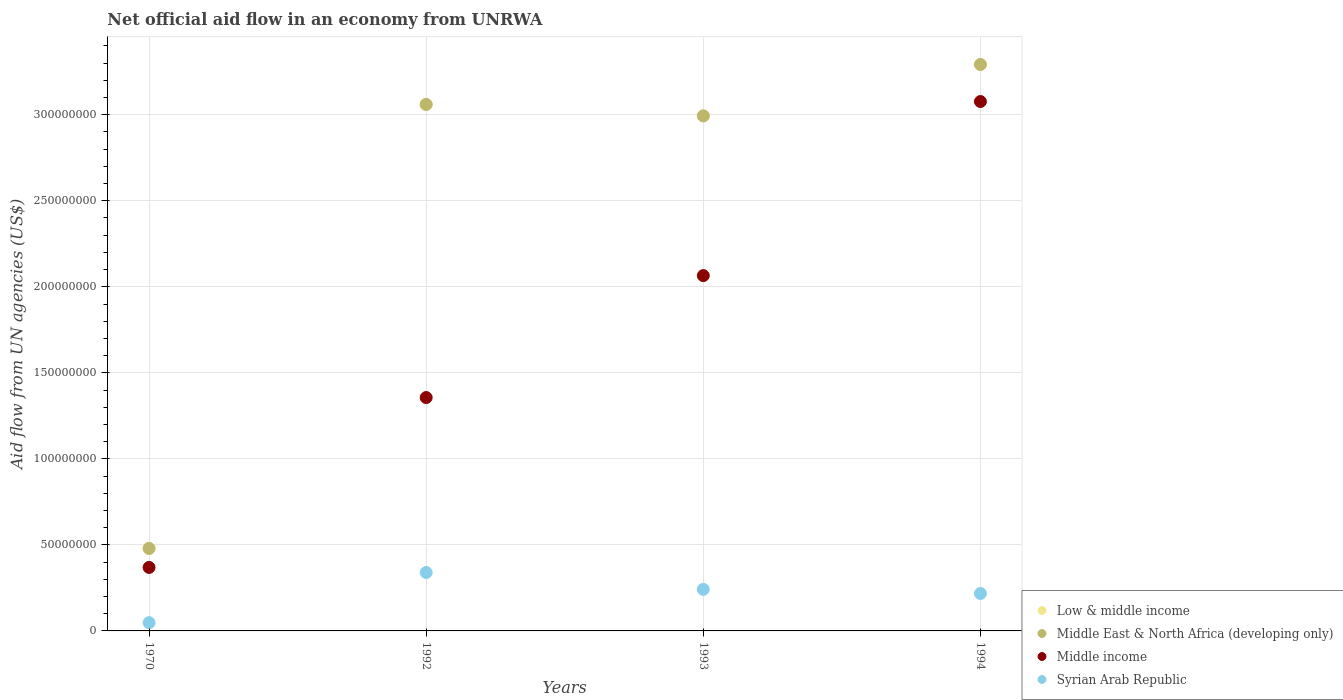What is the net official aid flow in Middle East & North Africa (developing only) in 1994?
Your answer should be compact. 3.29e+08. Across all years, what is the maximum net official aid flow in Middle East & North Africa (developing only)?
Make the answer very short. 3.29e+08. Across all years, what is the minimum net official aid flow in Syrian Arab Republic?
Your answer should be compact. 4.79e+06. What is the total net official aid flow in Middle East & North Africa (developing only) in the graph?
Offer a terse response. 9.82e+08. What is the difference between the net official aid flow in Low & middle income in 1970 and that in 1992?
Make the answer very short. -2.58e+08. What is the difference between the net official aid flow in Middle East & North Africa (developing only) in 1992 and the net official aid flow in Syrian Arab Republic in 1970?
Your answer should be very brief. 3.01e+08. What is the average net official aid flow in Middle income per year?
Provide a short and direct response. 1.72e+08. In the year 1994, what is the difference between the net official aid flow in Middle income and net official aid flow in Low & middle income?
Make the answer very short. -2.15e+07. What is the ratio of the net official aid flow in Syrian Arab Republic in 1992 to that in 1994?
Your answer should be very brief. 1.56. Is the net official aid flow in Syrian Arab Republic in 1970 less than that in 1992?
Your response must be concise. Yes. Is the difference between the net official aid flow in Middle income in 1970 and 1993 greater than the difference between the net official aid flow in Low & middle income in 1970 and 1993?
Offer a terse response. Yes. What is the difference between the highest and the second highest net official aid flow in Middle East & North Africa (developing only)?
Your answer should be very brief. 2.32e+07. What is the difference between the highest and the lowest net official aid flow in Low & middle income?
Offer a very short reply. 2.81e+08. Is it the case that in every year, the sum of the net official aid flow in Middle East & North Africa (developing only) and net official aid flow in Low & middle income  is greater than the net official aid flow in Syrian Arab Republic?
Ensure brevity in your answer.  Yes. Does the net official aid flow in Low & middle income monotonically increase over the years?
Keep it short and to the point. No. Is the net official aid flow in Middle income strictly greater than the net official aid flow in Middle East & North Africa (developing only) over the years?
Make the answer very short. No. Is the net official aid flow in Middle East & North Africa (developing only) strictly less than the net official aid flow in Low & middle income over the years?
Make the answer very short. No. Does the graph contain any zero values?
Your answer should be very brief. No. Where does the legend appear in the graph?
Keep it short and to the point. Bottom right. How many legend labels are there?
Keep it short and to the point. 4. How are the legend labels stacked?
Provide a succinct answer. Vertical. What is the title of the graph?
Provide a short and direct response. Net official aid flow in an economy from UNRWA. Does "Congo (Democratic)" appear as one of the legend labels in the graph?
Ensure brevity in your answer.  No. What is the label or title of the Y-axis?
Your answer should be compact. Aid flow from UN agencies (US$). What is the Aid flow from UN agencies (US$) of Low & middle income in 1970?
Give a very brief answer. 4.79e+07. What is the Aid flow from UN agencies (US$) in Middle East & North Africa (developing only) in 1970?
Your answer should be very brief. 4.79e+07. What is the Aid flow from UN agencies (US$) of Middle income in 1970?
Keep it short and to the point. 3.69e+07. What is the Aid flow from UN agencies (US$) of Syrian Arab Republic in 1970?
Your response must be concise. 4.79e+06. What is the Aid flow from UN agencies (US$) in Low & middle income in 1992?
Provide a short and direct response. 3.06e+08. What is the Aid flow from UN agencies (US$) of Middle East & North Africa (developing only) in 1992?
Offer a terse response. 3.06e+08. What is the Aid flow from UN agencies (US$) of Middle income in 1992?
Offer a terse response. 1.36e+08. What is the Aid flow from UN agencies (US$) in Syrian Arab Republic in 1992?
Provide a short and direct response. 3.40e+07. What is the Aid flow from UN agencies (US$) of Low & middle income in 1993?
Your response must be concise. 2.99e+08. What is the Aid flow from UN agencies (US$) of Middle East & North Africa (developing only) in 1993?
Provide a short and direct response. 2.99e+08. What is the Aid flow from UN agencies (US$) of Middle income in 1993?
Provide a short and direct response. 2.07e+08. What is the Aid flow from UN agencies (US$) of Syrian Arab Republic in 1993?
Offer a terse response. 2.42e+07. What is the Aid flow from UN agencies (US$) of Low & middle income in 1994?
Offer a terse response. 3.29e+08. What is the Aid flow from UN agencies (US$) in Middle East & North Africa (developing only) in 1994?
Make the answer very short. 3.29e+08. What is the Aid flow from UN agencies (US$) in Middle income in 1994?
Your response must be concise. 3.08e+08. What is the Aid flow from UN agencies (US$) in Syrian Arab Republic in 1994?
Keep it short and to the point. 2.18e+07. Across all years, what is the maximum Aid flow from UN agencies (US$) of Low & middle income?
Ensure brevity in your answer.  3.29e+08. Across all years, what is the maximum Aid flow from UN agencies (US$) of Middle East & North Africa (developing only)?
Your answer should be compact. 3.29e+08. Across all years, what is the maximum Aid flow from UN agencies (US$) in Middle income?
Provide a short and direct response. 3.08e+08. Across all years, what is the maximum Aid flow from UN agencies (US$) in Syrian Arab Republic?
Offer a very short reply. 3.40e+07. Across all years, what is the minimum Aid flow from UN agencies (US$) in Low & middle income?
Your answer should be compact. 4.79e+07. Across all years, what is the minimum Aid flow from UN agencies (US$) in Middle East & North Africa (developing only)?
Offer a terse response. 4.79e+07. Across all years, what is the minimum Aid flow from UN agencies (US$) in Middle income?
Keep it short and to the point. 3.69e+07. Across all years, what is the minimum Aid flow from UN agencies (US$) in Syrian Arab Republic?
Offer a very short reply. 4.79e+06. What is the total Aid flow from UN agencies (US$) of Low & middle income in the graph?
Ensure brevity in your answer.  9.82e+08. What is the total Aid flow from UN agencies (US$) in Middle East & North Africa (developing only) in the graph?
Your answer should be very brief. 9.82e+08. What is the total Aid flow from UN agencies (US$) of Middle income in the graph?
Give a very brief answer. 6.87e+08. What is the total Aid flow from UN agencies (US$) of Syrian Arab Republic in the graph?
Offer a very short reply. 8.46e+07. What is the difference between the Aid flow from UN agencies (US$) in Low & middle income in 1970 and that in 1992?
Your answer should be compact. -2.58e+08. What is the difference between the Aid flow from UN agencies (US$) in Middle East & North Africa (developing only) in 1970 and that in 1992?
Make the answer very short. -2.58e+08. What is the difference between the Aid flow from UN agencies (US$) in Middle income in 1970 and that in 1992?
Give a very brief answer. -9.87e+07. What is the difference between the Aid flow from UN agencies (US$) in Syrian Arab Republic in 1970 and that in 1992?
Your answer should be compact. -2.92e+07. What is the difference between the Aid flow from UN agencies (US$) in Low & middle income in 1970 and that in 1993?
Provide a succinct answer. -2.51e+08. What is the difference between the Aid flow from UN agencies (US$) of Middle East & North Africa (developing only) in 1970 and that in 1993?
Your answer should be very brief. -2.51e+08. What is the difference between the Aid flow from UN agencies (US$) in Middle income in 1970 and that in 1993?
Your answer should be very brief. -1.70e+08. What is the difference between the Aid flow from UN agencies (US$) of Syrian Arab Republic in 1970 and that in 1993?
Offer a terse response. -1.94e+07. What is the difference between the Aid flow from UN agencies (US$) of Low & middle income in 1970 and that in 1994?
Offer a very short reply. -2.81e+08. What is the difference between the Aid flow from UN agencies (US$) of Middle East & North Africa (developing only) in 1970 and that in 1994?
Your answer should be compact. -2.81e+08. What is the difference between the Aid flow from UN agencies (US$) of Middle income in 1970 and that in 1994?
Your answer should be very brief. -2.71e+08. What is the difference between the Aid flow from UN agencies (US$) of Syrian Arab Republic in 1970 and that in 1994?
Your answer should be compact. -1.70e+07. What is the difference between the Aid flow from UN agencies (US$) of Low & middle income in 1992 and that in 1993?
Keep it short and to the point. 6.65e+06. What is the difference between the Aid flow from UN agencies (US$) in Middle East & North Africa (developing only) in 1992 and that in 1993?
Ensure brevity in your answer.  6.65e+06. What is the difference between the Aid flow from UN agencies (US$) in Middle income in 1992 and that in 1993?
Your answer should be very brief. -7.09e+07. What is the difference between the Aid flow from UN agencies (US$) in Syrian Arab Republic in 1992 and that in 1993?
Make the answer very short. 9.80e+06. What is the difference between the Aid flow from UN agencies (US$) of Low & middle income in 1992 and that in 1994?
Provide a succinct answer. -2.32e+07. What is the difference between the Aid flow from UN agencies (US$) of Middle East & North Africa (developing only) in 1992 and that in 1994?
Your response must be concise. -2.32e+07. What is the difference between the Aid flow from UN agencies (US$) in Middle income in 1992 and that in 1994?
Your response must be concise. -1.72e+08. What is the difference between the Aid flow from UN agencies (US$) of Syrian Arab Republic in 1992 and that in 1994?
Give a very brief answer. 1.22e+07. What is the difference between the Aid flow from UN agencies (US$) in Low & middle income in 1993 and that in 1994?
Give a very brief answer. -2.99e+07. What is the difference between the Aid flow from UN agencies (US$) in Middle East & North Africa (developing only) in 1993 and that in 1994?
Make the answer very short. -2.99e+07. What is the difference between the Aid flow from UN agencies (US$) of Middle income in 1993 and that in 1994?
Keep it short and to the point. -1.01e+08. What is the difference between the Aid flow from UN agencies (US$) of Syrian Arab Republic in 1993 and that in 1994?
Keep it short and to the point. 2.40e+06. What is the difference between the Aid flow from UN agencies (US$) of Low & middle income in 1970 and the Aid flow from UN agencies (US$) of Middle East & North Africa (developing only) in 1992?
Offer a terse response. -2.58e+08. What is the difference between the Aid flow from UN agencies (US$) of Low & middle income in 1970 and the Aid flow from UN agencies (US$) of Middle income in 1992?
Make the answer very short. -8.77e+07. What is the difference between the Aid flow from UN agencies (US$) of Low & middle income in 1970 and the Aid flow from UN agencies (US$) of Syrian Arab Republic in 1992?
Ensure brevity in your answer.  1.40e+07. What is the difference between the Aid flow from UN agencies (US$) in Middle East & North Africa (developing only) in 1970 and the Aid flow from UN agencies (US$) in Middle income in 1992?
Offer a very short reply. -8.77e+07. What is the difference between the Aid flow from UN agencies (US$) in Middle East & North Africa (developing only) in 1970 and the Aid flow from UN agencies (US$) in Syrian Arab Republic in 1992?
Your answer should be very brief. 1.40e+07. What is the difference between the Aid flow from UN agencies (US$) in Middle income in 1970 and the Aid flow from UN agencies (US$) in Syrian Arab Republic in 1992?
Give a very brief answer. 2.95e+06. What is the difference between the Aid flow from UN agencies (US$) in Low & middle income in 1970 and the Aid flow from UN agencies (US$) in Middle East & North Africa (developing only) in 1993?
Your response must be concise. -2.51e+08. What is the difference between the Aid flow from UN agencies (US$) in Low & middle income in 1970 and the Aid flow from UN agencies (US$) in Middle income in 1993?
Keep it short and to the point. -1.59e+08. What is the difference between the Aid flow from UN agencies (US$) in Low & middle income in 1970 and the Aid flow from UN agencies (US$) in Syrian Arab Republic in 1993?
Keep it short and to the point. 2.38e+07. What is the difference between the Aid flow from UN agencies (US$) of Middle East & North Africa (developing only) in 1970 and the Aid flow from UN agencies (US$) of Middle income in 1993?
Give a very brief answer. -1.59e+08. What is the difference between the Aid flow from UN agencies (US$) in Middle East & North Africa (developing only) in 1970 and the Aid flow from UN agencies (US$) in Syrian Arab Republic in 1993?
Make the answer very short. 2.38e+07. What is the difference between the Aid flow from UN agencies (US$) in Middle income in 1970 and the Aid flow from UN agencies (US$) in Syrian Arab Republic in 1993?
Ensure brevity in your answer.  1.28e+07. What is the difference between the Aid flow from UN agencies (US$) of Low & middle income in 1970 and the Aid flow from UN agencies (US$) of Middle East & North Africa (developing only) in 1994?
Your response must be concise. -2.81e+08. What is the difference between the Aid flow from UN agencies (US$) of Low & middle income in 1970 and the Aid flow from UN agencies (US$) of Middle income in 1994?
Provide a succinct answer. -2.60e+08. What is the difference between the Aid flow from UN agencies (US$) of Low & middle income in 1970 and the Aid flow from UN agencies (US$) of Syrian Arab Republic in 1994?
Provide a short and direct response. 2.62e+07. What is the difference between the Aid flow from UN agencies (US$) of Middle East & North Africa (developing only) in 1970 and the Aid flow from UN agencies (US$) of Middle income in 1994?
Keep it short and to the point. -2.60e+08. What is the difference between the Aid flow from UN agencies (US$) in Middle East & North Africa (developing only) in 1970 and the Aid flow from UN agencies (US$) in Syrian Arab Republic in 1994?
Your answer should be compact. 2.62e+07. What is the difference between the Aid flow from UN agencies (US$) of Middle income in 1970 and the Aid flow from UN agencies (US$) of Syrian Arab Republic in 1994?
Give a very brief answer. 1.52e+07. What is the difference between the Aid flow from UN agencies (US$) in Low & middle income in 1992 and the Aid flow from UN agencies (US$) in Middle East & North Africa (developing only) in 1993?
Your answer should be compact. 6.65e+06. What is the difference between the Aid flow from UN agencies (US$) of Low & middle income in 1992 and the Aid flow from UN agencies (US$) of Middle income in 1993?
Ensure brevity in your answer.  9.95e+07. What is the difference between the Aid flow from UN agencies (US$) of Low & middle income in 1992 and the Aid flow from UN agencies (US$) of Syrian Arab Republic in 1993?
Provide a short and direct response. 2.82e+08. What is the difference between the Aid flow from UN agencies (US$) in Middle East & North Africa (developing only) in 1992 and the Aid flow from UN agencies (US$) in Middle income in 1993?
Offer a very short reply. 9.95e+07. What is the difference between the Aid flow from UN agencies (US$) of Middle East & North Africa (developing only) in 1992 and the Aid flow from UN agencies (US$) of Syrian Arab Republic in 1993?
Provide a succinct answer. 2.82e+08. What is the difference between the Aid flow from UN agencies (US$) of Middle income in 1992 and the Aid flow from UN agencies (US$) of Syrian Arab Republic in 1993?
Ensure brevity in your answer.  1.11e+08. What is the difference between the Aid flow from UN agencies (US$) in Low & middle income in 1992 and the Aid flow from UN agencies (US$) in Middle East & North Africa (developing only) in 1994?
Your response must be concise. -2.32e+07. What is the difference between the Aid flow from UN agencies (US$) in Low & middle income in 1992 and the Aid flow from UN agencies (US$) in Middle income in 1994?
Keep it short and to the point. -1.70e+06. What is the difference between the Aid flow from UN agencies (US$) of Low & middle income in 1992 and the Aid flow from UN agencies (US$) of Syrian Arab Republic in 1994?
Keep it short and to the point. 2.84e+08. What is the difference between the Aid flow from UN agencies (US$) of Middle East & North Africa (developing only) in 1992 and the Aid flow from UN agencies (US$) of Middle income in 1994?
Your response must be concise. -1.70e+06. What is the difference between the Aid flow from UN agencies (US$) of Middle East & North Africa (developing only) in 1992 and the Aid flow from UN agencies (US$) of Syrian Arab Republic in 1994?
Provide a short and direct response. 2.84e+08. What is the difference between the Aid flow from UN agencies (US$) of Middle income in 1992 and the Aid flow from UN agencies (US$) of Syrian Arab Republic in 1994?
Provide a succinct answer. 1.14e+08. What is the difference between the Aid flow from UN agencies (US$) in Low & middle income in 1993 and the Aid flow from UN agencies (US$) in Middle East & North Africa (developing only) in 1994?
Provide a succinct answer. -2.99e+07. What is the difference between the Aid flow from UN agencies (US$) in Low & middle income in 1993 and the Aid flow from UN agencies (US$) in Middle income in 1994?
Your answer should be compact. -8.35e+06. What is the difference between the Aid flow from UN agencies (US$) of Low & middle income in 1993 and the Aid flow from UN agencies (US$) of Syrian Arab Republic in 1994?
Your answer should be very brief. 2.78e+08. What is the difference between the Aid flow from UN agencies (US$) of Middle East & North Africa (developing only) in 1993 and the Aid flow from UN agencies (US$) of Middle income in 1994?
Offer a very short reply. -8.35e+06. What is the difference between the Aid flow from UN agencies (US$) of Middle East & North Africa (developing only) in 1993 and the Aid flow from UN agencies (US$) of Syrian Arab Republic in 1994?
Give a very brief answer. 2.78e+08. What is the difference between the Aid flow from UN agencies (US$) of Middle income in 1993 and the Aid flow from UN agencies (US$) of Syrian Arab Republic in 1994?
Your answer should be very brief. 1.85e+08. What is the average Aid flow from UN agencies (US$) in Low & middle income per year?
Provide a short and direct response. 2.46e+08. What is the average Aid flow from UN agencies (US$) in Middle East & North Africa (developing only) per year?
Offer a very short reply. 2.46e+08. What is the average Aid flow from UN agencies (US$) of Middle income per year?
Provide a short and direct response. 1.72e+08. What is the average Aid flow from UN agencies (US$) in Syrian Arab Republic per year?
Provide a short and direct response. 2.12e+07. In the year 1970, what is the difference between the Aid flow from UN agencies (US$) of Low & middle income and Aid flow from UN agencies (US$) of Middle East & North Africa (developing only)?
Provide a succinct answer. 0. In the year 1970, what is the difference between the Aid flow from UN agencies (US$) in Low & middle income and Aid flow from UN agencies (US$) in Middle income?
Provide a succinct answer. 1.10e+07. In the year 1970, what is the difference between the Aid flow from UN agencies (US$) of Low & middle income and Aid flow from UN agencies (US$) of Syrian Arab Republic?
Your answer should be compact. 4.31e+07. In the year 1970, what is the difference between the Aid flow from UN agencies (US$) of Middle East & North Africa (developing only) and Aid flow from UN agencies (US$) of Middle income?
Make the answer very short. 1.10e+07. In the year 1970, what is the difference between the Aid flow from UN agencies (US$) in Middle East & North Africa (developing only) and Aid flow from UN agencies (US$) in Syrian Arab Republic?
Make the answer very short. 4.31e+07. In the year 1970, what is the difference between the Aid flow from UN agencies (US$) of Middle income and Aid flow from UN agencies (US$) of Syrian Arab Republic?
Ensure brevity in your answer.  3.21e+07. In the year 1992, what is the difference between the Aid flow from UN agencies (US$) in Low & middle income and Aid flow from UN agencies (US$) in Middle East & North Africa (developing only)?
Provide a succinct answer. 0. In the year 1992, what is the difference between the Aid flow from UN agencies (US$) in Low & middle income and Aid flow from UN agencies (US$) in Middle income?
Your answer should be very brief. 1.70e+08. In the year 1992, what is the difference between the Aid flow from UN agencies (US$) of Low & middle income and Aid flow from UN agencies (US$) of Syrian Arab Republic?
Offer a terse response. 2.72e+08. In the year 1992, what is the difference between the Aid flow from UN agencies (US$) of Middle East & North Africa (developing only) and Aid flow from UN agencies (US$) of Middle income?
Make the answer very short. 1.70e+08. In the year 1992, what is the difference between the Aid flow from UN agencies (US$) in Middle East & North Africa (developing only) and Aid flow from UN agencies (US$) in Syrian Arab Republic?
Make the answer very short. 2.72e+08. In the year 1992, what is the difference between the Aid flow from UN agencies (US$) of Middle income and Aid flow from UN agencies (US$) of Syrian Arab Republic?
Offer a terse response. 1.02e+08. In the year 1993, what is the difference between the Aid flow from UN agencies (US$) in Low & middle income and Aid flow from UN agencies (US$) in Middle income?
Your answer should be very brief. 9.28e+07. In the year 1993, what is the difference between the Aid flow from UN agencies (US$) in Low & middle income and Aid flow from UN agencies (US$) in Syrian Arab Republic?
Ensure brevity in your answer.  2.75e+08. In the year 1993, what is the difference between the Aid flow from UN agencies (US$) of Middle East & North Africa (developing only) and Aid flow from UN agencies (US$) of Middle income?
Offer a very short reply. 9.28e+07. In the year 1993, what is the difference between the Aid flow from UN agencies (US$) of Middle East & North Africa (developing only) and Aid flow from UN agencies (US$) of Syrian Arab Republic?
Give a very brief answer. 2.75e+08. In the year 1993, what is the difference between the Aid flow from UN agencies (US$) of Middle income and Aid flow from UN agencies (US$) of Syrian Arab Republic?
Keep it short and to the point. 1.82e+08. In the year 1994, what is the difference between the Aid flow from UN agencies (US$) of Low & middle income and Aid flow from UN agencies (US$) of Middle income?
Your answer should be compact. 2.15e+07. In the year 1994, what is the difference between the Aid flow from UN agencies (US$) of Low & middle income and Aid flow from UN agencies (US$) of Syrian Arab Republic?
Your response must be concise. 3.07e+08. In the year 1994, what is the difference between the Aid flow from UN agencies (US$) in Middle East & North Africa (developing only) and Aid flow from UN agencies (US$) in Middle income?
Provide a short and direct response. 2.15e+07. In the year 1994, what is the difference between the Aid flow from UN agencies (US$) of Middle East & North Africa (developing only) and Aid flow from UN agencies (US$) of Syrian Arab Republic?
Provide a succinct answer. 3.07e+08. In the year 1994, what is the difference between the Aid flow from UN agencies (US$) of Middle income and Aid flow from UN agencies (US$) of Syrian Arab Republic?
Your answer should be very brief. 2.86e+08. What is the ratio of the Aid flow from UN agencies (US$) of Low & middle income in 1970 to that in 1992?
Your answer should be compact. 0.16. What is the ratio of the Aid flow from UN agencies (US$) of Middle East & North Africa (developing only) in 1970 to that in 1992?
Your answer should be compact. 0.16. What is the ratio of the Aid flow from UN agencies (US$) in Middle income in 1970 to that in 1992?
Your answer should be very brief. 0.27. What is the ratio of the Aid flow from UN agencies (US$) of Syrian Arab Republic in 1970 to that in 1992?
Provide a succinct answer. 0.14. What is the ratio of the Aid flow from UN agencies (US$) in Low & middle income in 1970 to that in 1993?
Your answer should be compact. 0.16. What is the ratio of the Aid flow from UN agencies (US$) of Middle East & North Africa (developing only) in 1970 to that in 1993?
Offer a very short reply. 0.16. What is the ratio of the Aid flow from UN agencies (US$) in Middle income in 1970 to that in 1993?
Ensure brevity in your answer.  0.18. What is the ratio of the Aid flow from UN agencies (US$) in Syrian Arab Republic in 1970 to that in 1993?
Ensure brevity in your answer.  0.2. What is the ratio of the Aid flow from UN agencies (US$) in Low & middle income in 1970 to that in 1994?
Offer a terse response. 0.15. What is the ratio of the Aid flow from UN agencies (US$) of Middle East & North Africa (developing only) in 1970 to that in 1994?
Provide a short and direct response. 0.15. What is the ratio of the Aid flow from UN agencies (US$) in Middle income in 1970 to that in 1994?
Offer a terse response. 0.12. What is the ratio of the Aid flow from UN agencies (US$) in Syrian Arab Republic in 1970 to that in 1994?
Ensure brevity in your answer.  0.22. What is the ratio of the Aid flow from UN agencies (US$) in Low & middle income in 1992 to that in 1993?
Offer a terse response. 1.02. What is the ratio of the Aid flow from UN agencies (US$) of Middle East & North Africa (developing only) in 1992 to that in 1993?
Offer a very short reply. 1.02. What is the ratio of the Aid flow from UN agencies (US$) in Middle income in 1992 to that in 1993?
Ensure brevity in your answer.  0.66. What is the ratio of the Aid flow from UN agencies (US$) in Syrian Arab Republic in 1992 to that in 1993?
Provide a short and direct response. 1.41. What is the ratio of the Aid flow from UN agencies (US$) of Low & middle income in 1992 to that in 1994?
Keep it short and to the point. 0.93. What is the ratio of the Aid flow from UN agencies (US$) of Middle East & North Africa (developing only) in 1992 to that in 1994?
Make the answer very short. 0.93. What is the ratio of the Aid flow from UN agencies (US$) of Middle income in 1992 to that in 1994?
Offer a terse response. 0.44. What is the ratio of the Aid flow from UN agencies (US$) of Syrian Arab Republic in 1992 to that in 1994?
Your answer should be compact. 1.56. What is the ratio of the Aid flow from UN agencies (US$) in Low & middle income in 1993 to that in 1994?
Provide a short and direct response. 0.91. What is the ratio of the Aid flow from UN agencies (US$) in Middle East & North Africa (developing only) in 1993 to that in 1994?
Keep it short and to the point. 0.91. What is the ratio of the Aid flow from UN agencies (US$) in Middle income in 1993 to that in 1994?
Make the answer very short. 0.67. What is the ratio of the Aid flow from UN agencies (US$) in Syrian Arab Republic in 1993 to that in 1994?
Your response must be concise. 1.11. What is the difference between the highest and the second highest Aid flow from UN agencies (US$) in Low & middle income?
Give a very brief answer. 2.32e+07. What is the difference between the highest and the second highest Aid flow from UN agencies (US$) of Middle East & North Africa (developing only)?
Your response must be concise. 2.32e+07. What is the difference between the highest and the second highest Aid flow from UN agencies (US$) in Middle income?
Give a very brief answer. 1.01e+08. What is the difference between the highest and the second highest Aid flow from UN agencies (US$) of Syrian Arab Republic?
Give a very brief answer. 9.80e+06. What is the difference between the highest and the lowest Aid flow from UN agencies (US$) in Low & middle income?
Offer a very short reply. 2.81e+08. What is the difference between the highest and the lowest Aid flow from UN agencies (US$) in Middle East & North Africa (developing only)?
Provide a short and direct response. 2.81e+08. What is the difference between the highest and the lowest Aid flow from UN agencies (US$) of Middle income?
Your answer should be compact. 2.71e+08. What is the difference between the highest and the lowest Aid flow from UN agencies (US$) in Syrian Arab Republic?
Your response must be concise. 2.92e+07. 